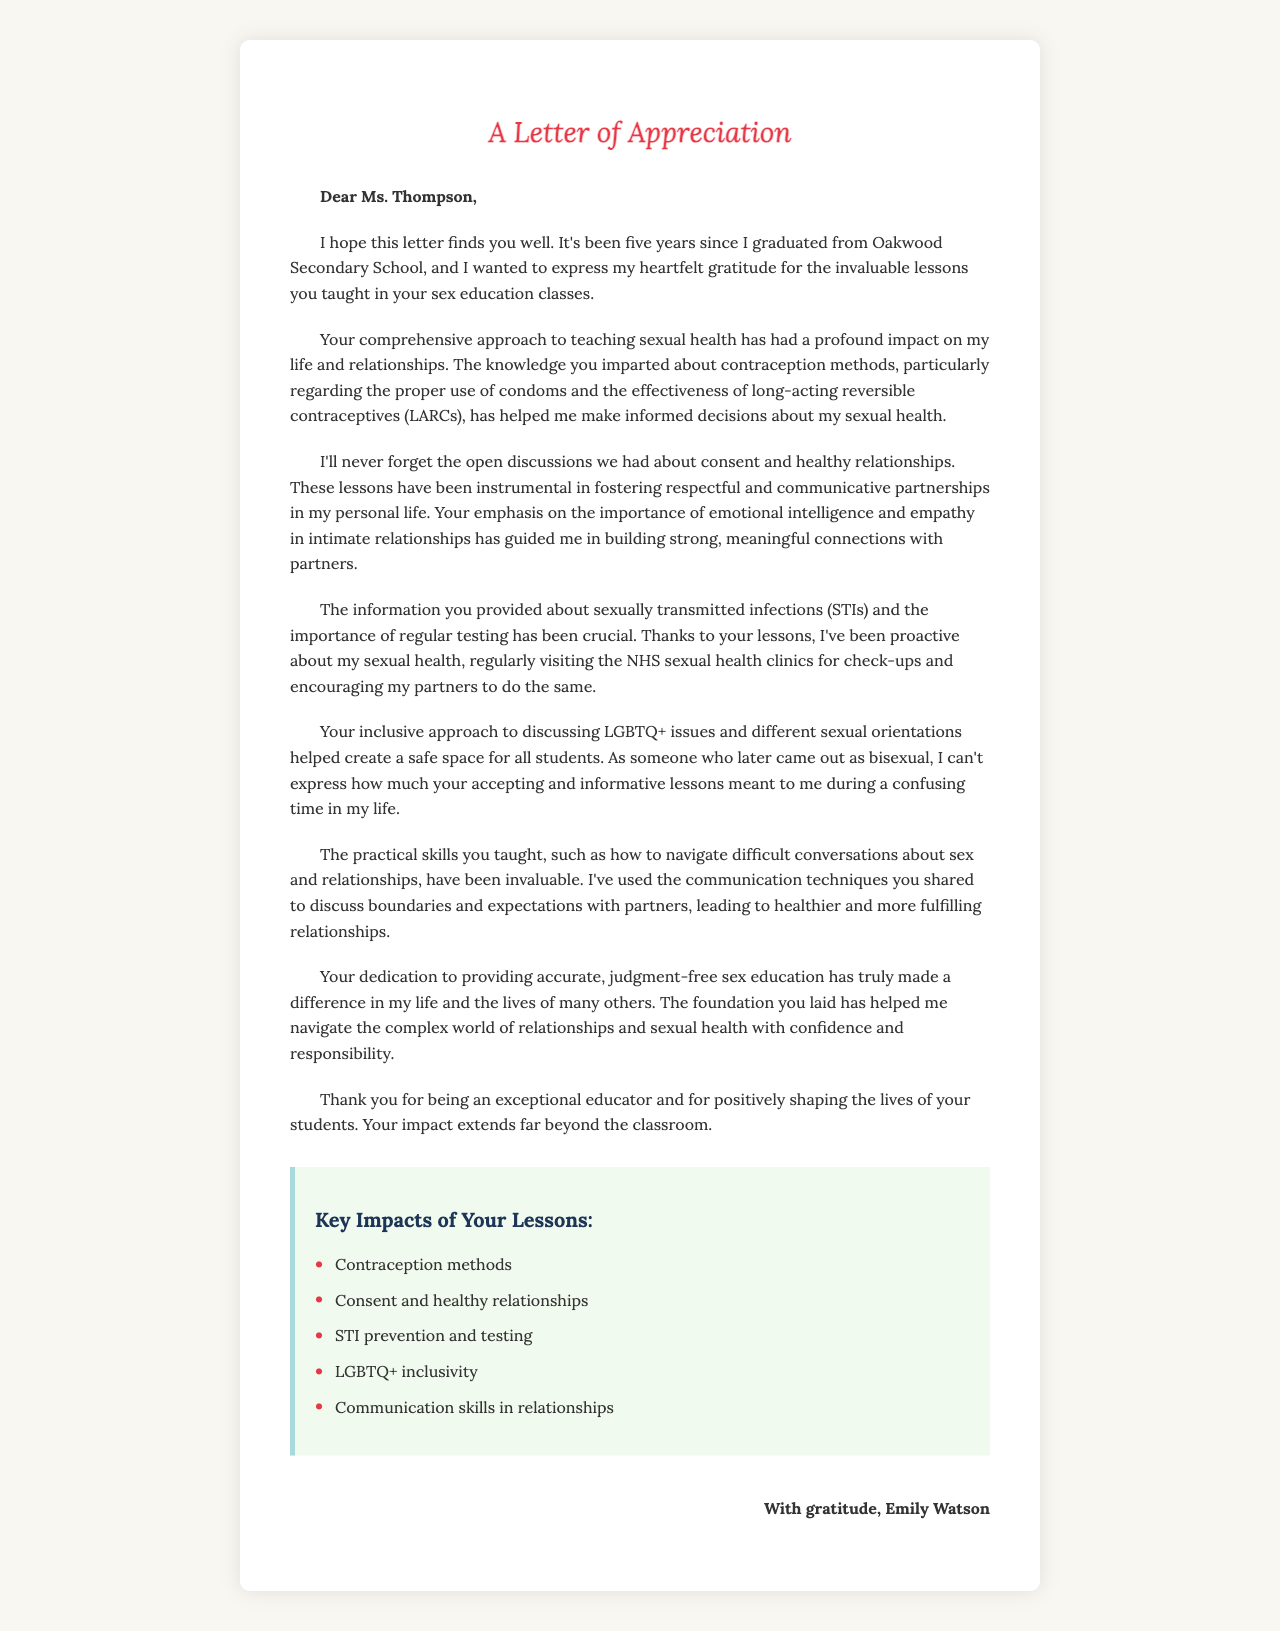What is the teacher's name? The teacher's name is mentioned in the greeting of the letter.
Answer: Ms. Thompson What school did the student graduate from? The school is cited in the opening paragraph of the letter.
Answer: Oakwood Secondary School What year did Emily Watson graduate? This information is provided in the student details.
Answer: 2018 How many years has it been since the student graduated? The letter states the time since graduation.
Answer: Five years What method of contraception was emphasized regarding proper use? This is mentioned in the first body paragraph about contraception methods.
Answer: Condoms What has the student regularly encouraged their partners to do? This is discussed in the context of STI prevention and testing.
Answer: Get check-ups Which sexual orientation does the former student identify with? The student's identification is mentioned in the fourth body paragraph.
Answer: Bisexual What key skill did the lessons help the student develop regarding partners? This skill is highlighted in the fifth body paragraph of the letter.
Answer: Communication What is Emily Watson’s age now? This detail is provided in the student information section.
Answer: 23 